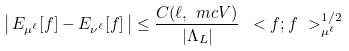Convert formula to latex. <formula><loc_0><loc_0><loc_500><loc_500>\left | \, E _ { \mu ^ { \ell } } [ f ] - E _ { \nu ^ { \ell } } [ f ] \, \right | \leq \frac { C ( \ell , \ m c V ) } { | \Lambda _ { L } | } \, \ < f ; f \ > ^ { 1 / 2 } _ { \mu ^ { \ell } }</formula> 